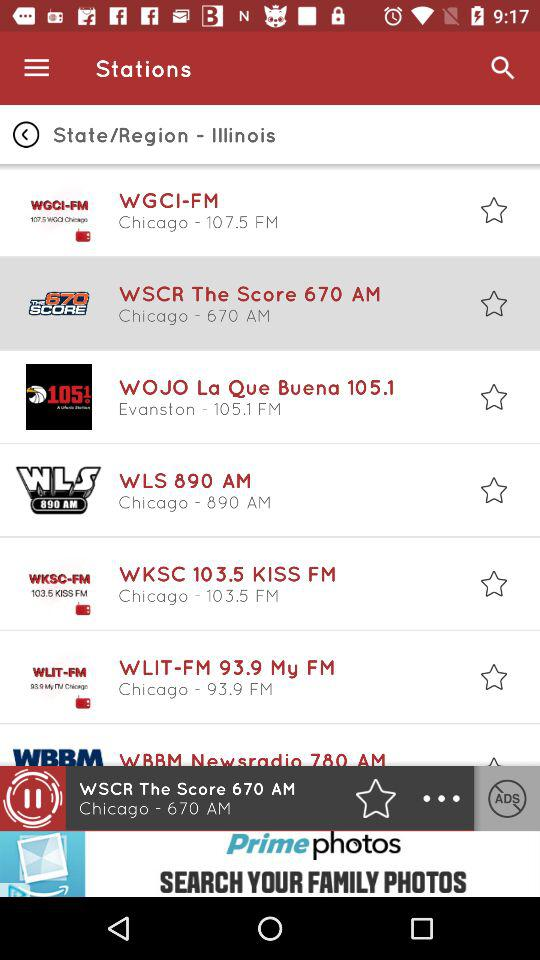The "WOJO La Que Buena 105.1" station broadcast on what frequency? It is broadcast on 105.1 frequency. 